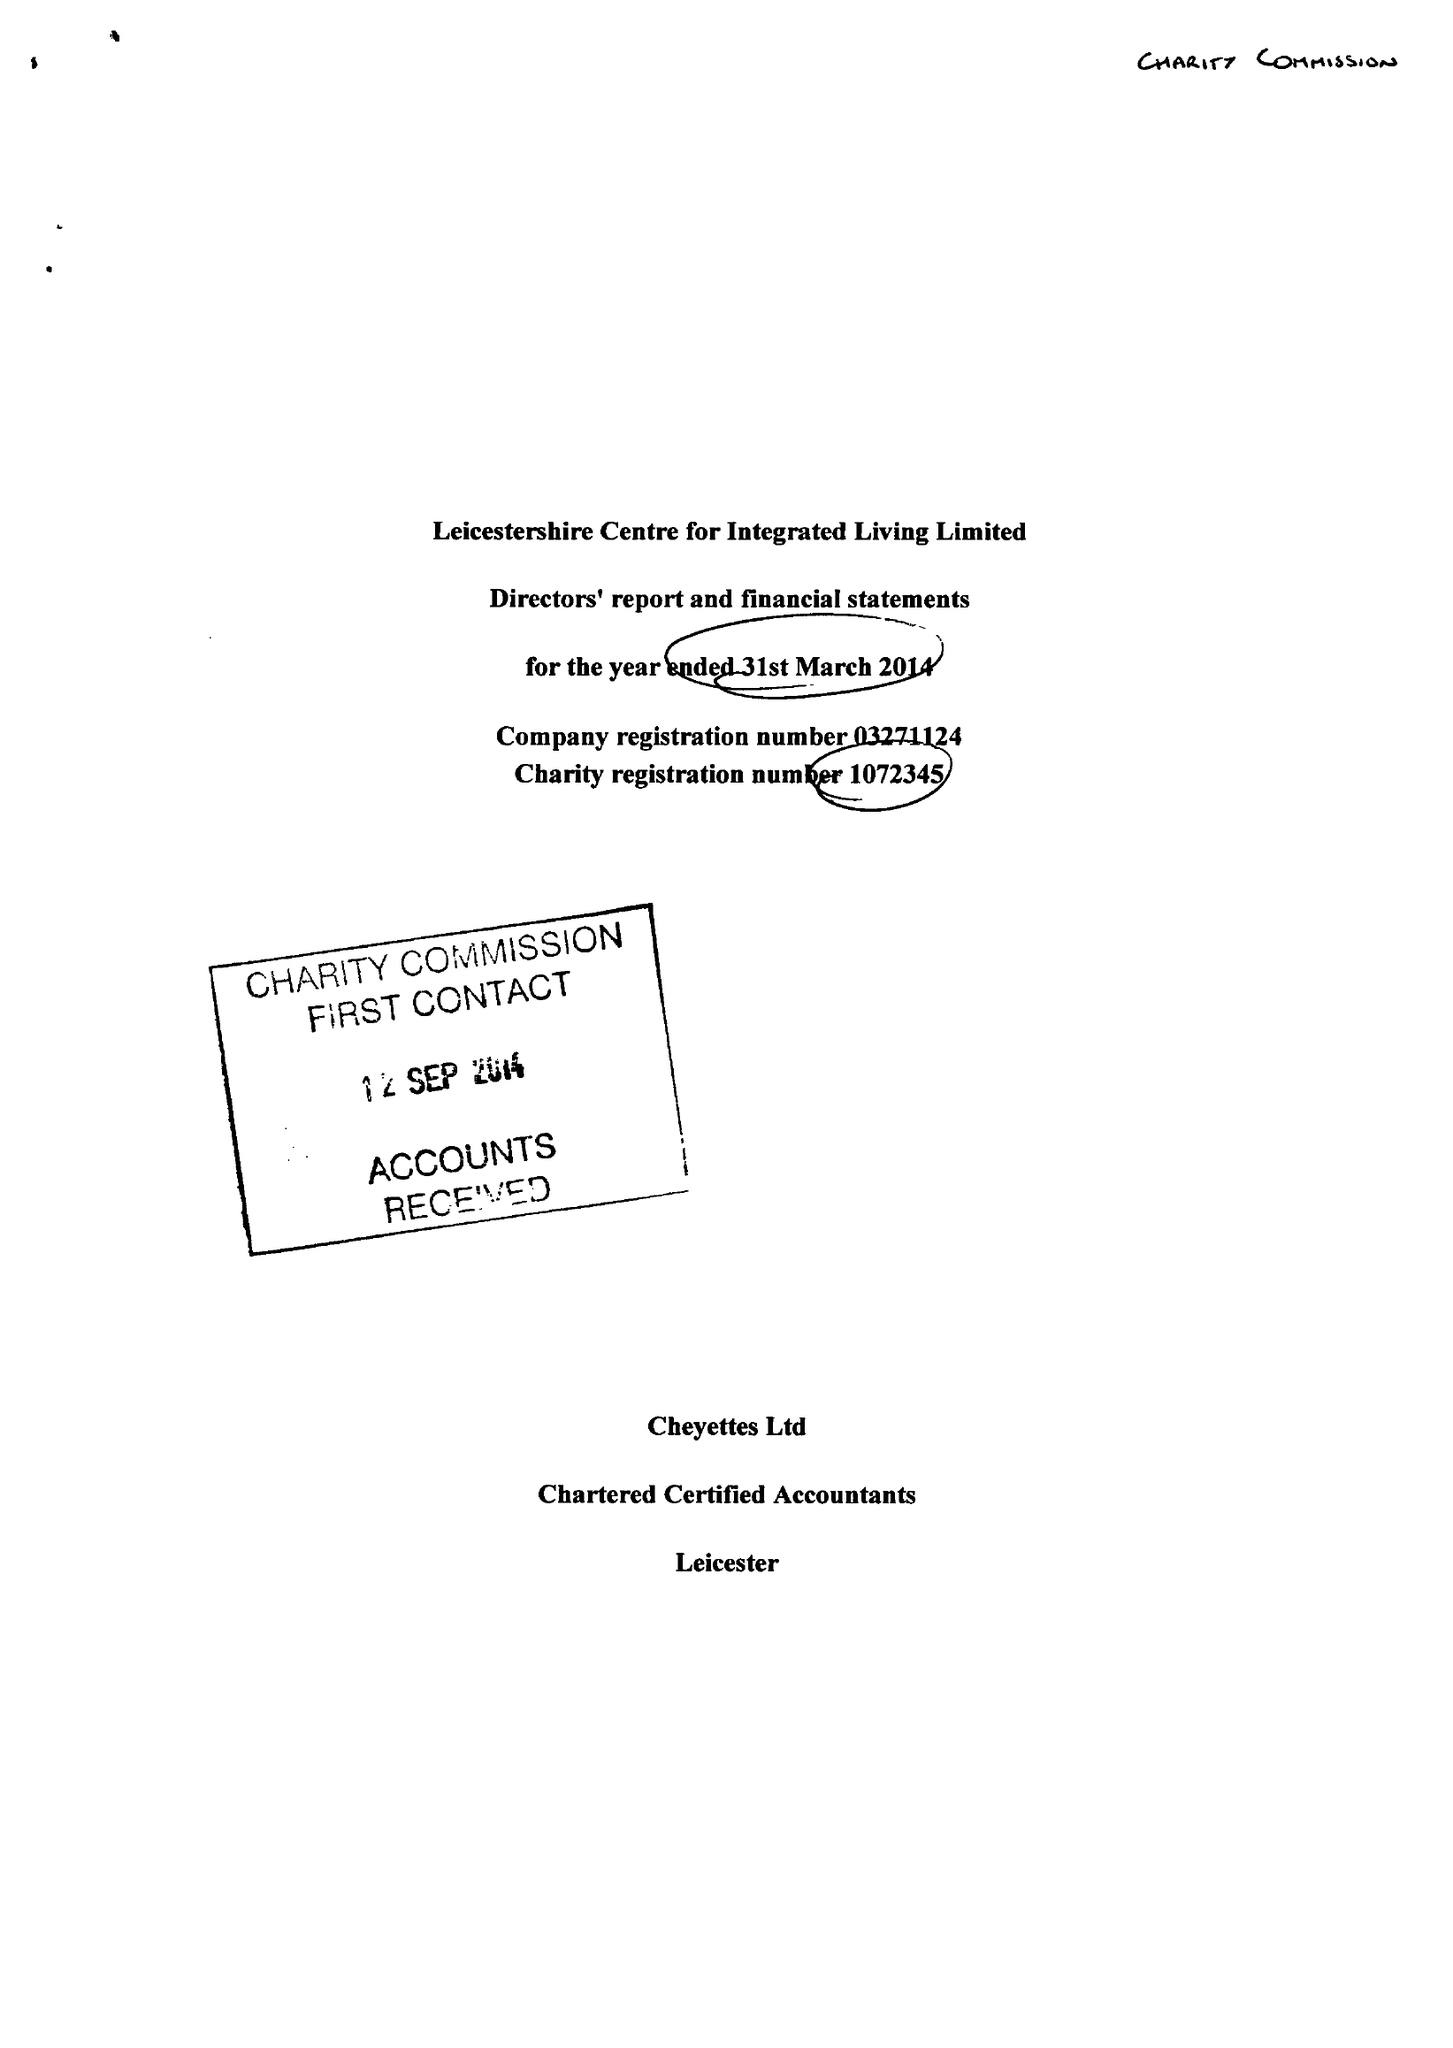What is the value for the charity_name?
Answer the question using a single word or phrase. Leicestershire Centre For Integrated Living Ltd. 